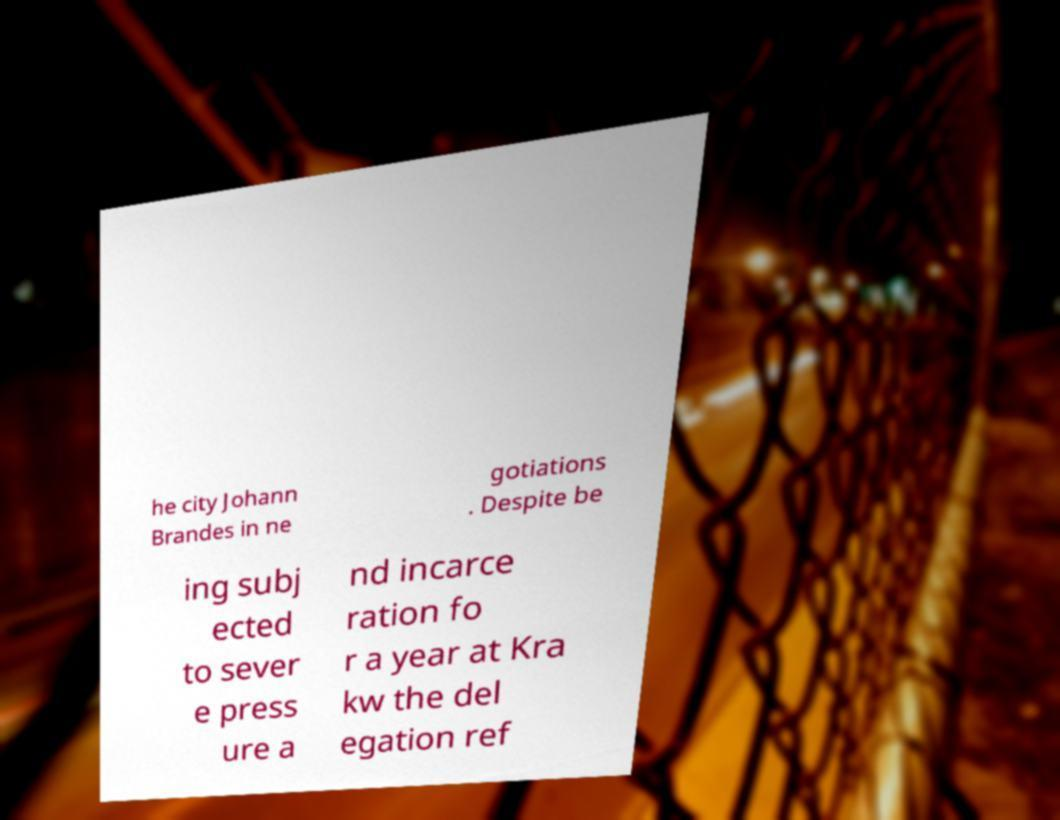Please identify and transcribe the text found in this image. he city Johann Brandes in ne gotiations . Despite be ing subj ected to sever e press ure a nd incarce ration fo r a year at Kra kw the del egation ref 